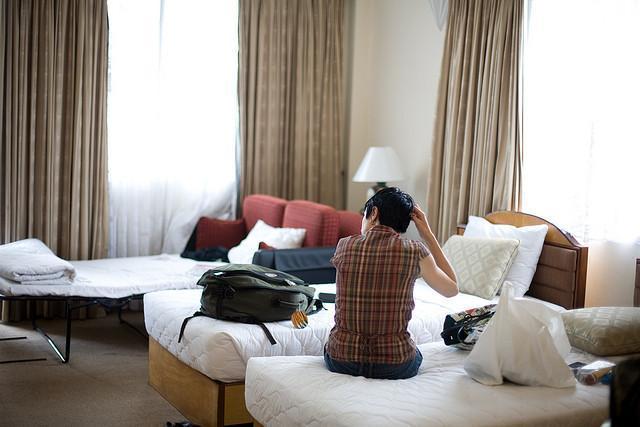How many beds are here?
Give a very brief answer. 3. How many couches can you see?
Give a very brief answer. 1. How many beds are in the picture?
Give a very brief answer. 3. 